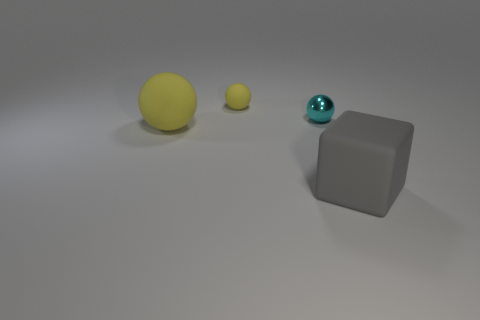Add 4 small cyan objects. How many objects exist? 8 Subtract all tiny spheres. How many spheres are left? 1 Subtract all cyan cubes. How many yellow spheres are left? 2 Subtract all cyan spheres. How many spheres are left? 2 Subtract 1 balls. How many balls are left? 2 Subtract all balls. How many objects are left? 1 Add 3 big blue metal cylinders. How many big blue metal cylinders exist? 3 Subtract 0 blue blocks. How many objects are left? 4 Subtract all green spheres. Subtract all cyan cylinders. How many spheres are left? 3 Subtract all large gray objects. Subtract all gray rubber blocks. How many objects are left? 2 